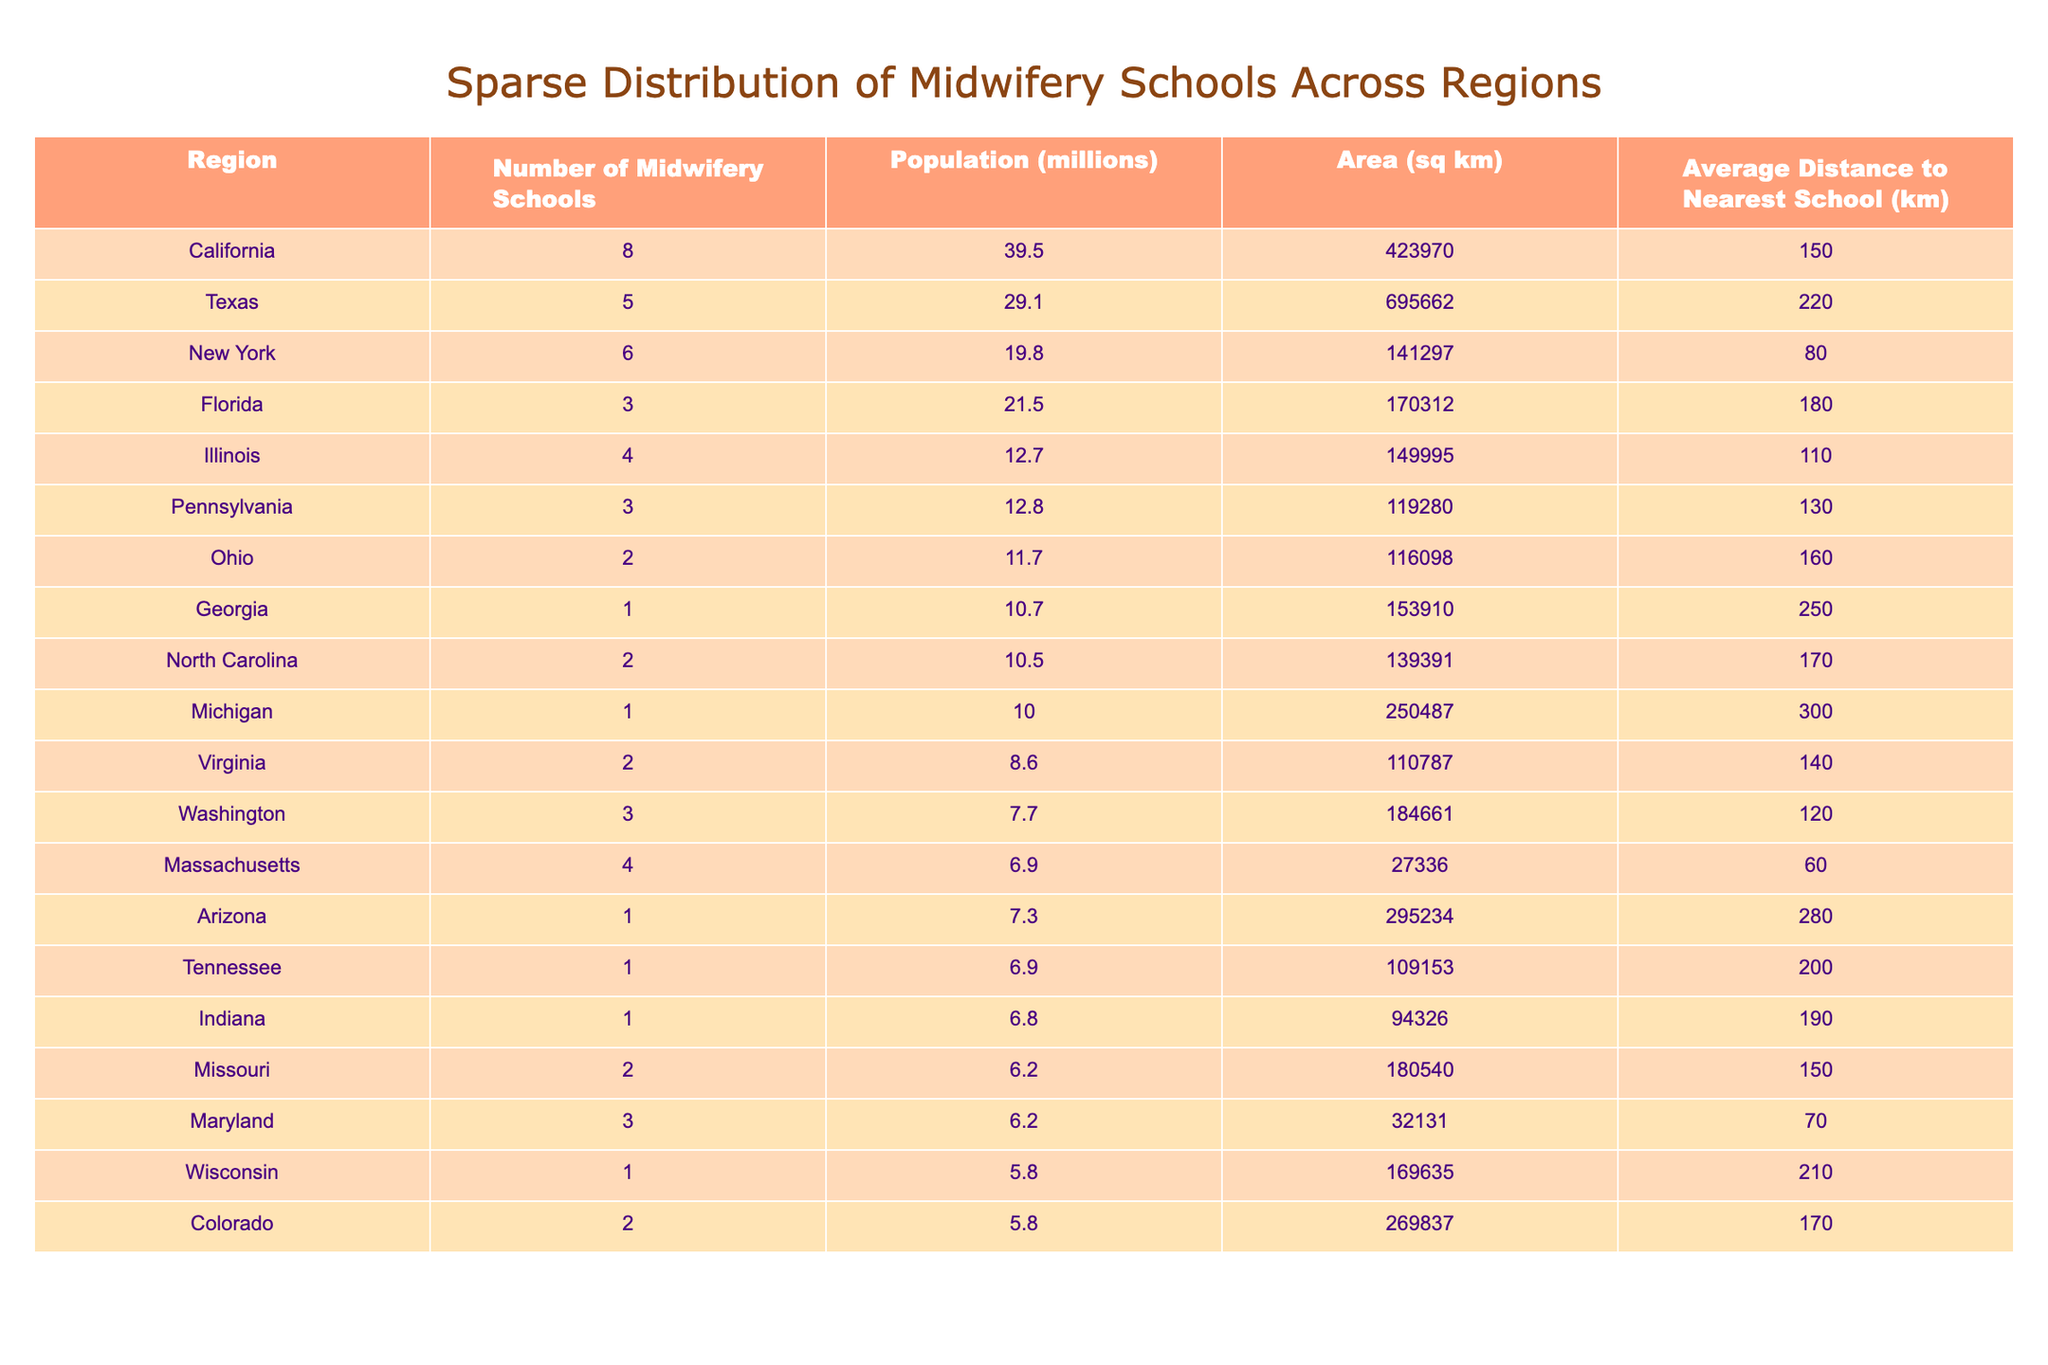What region has the highest number of midwifery schools? By looking at the "Number of Midwifery Schools" column, California has the highest number with 8 schools.
Answer: California Which region has the lowest average distance to the nearest midwifery school? The "Average Distance to Nearest School" column shows that Massachusetts has the lowest average distance at 60 km.
Answer: Massachusetts What is the total number of midwifery schools across all regions? To find the total, sum the values in the "Number of Midwifery Schools" column: 8 + 5 + 6 + 3 + 4 + 3 + 2 + 1 + 2 + 1 + 2 + 3 + 4 + 1 + 1 + 1 + 2 + 3 + 1 + 2 = 56.
Answer: 56 What is the average distance to the nearest midwifery school across all regions? First, calculate the sum of the "Average Distance to Nearest School" column (150 + 220 + 80 + 180 + 110 + 130 + 160 + 250 + 170 + 300 + 140 + 120 + 60 + 280 + 200 + 190 + 150 + 70 + 210 + 170 = 3080) and divide by 20 (the number of regions), resulting in an average of 154 km.
Answer: 154 km Is there a region with no midwifery schools? By checking the "Number of Midwifery Schools" column, Georgia, Michigan, Arizona, Tennessee, and Indiana each has only 1 school, indicating no region has zero schools.
Answer: No What is the total population of regions with more than 4 midwifery schools? First, identify the regions with more than 4 schools: California (39.5), Texas (29.1), and New York (19.8). Summing their populations gives 39.5 + 29.1 + 19.8 = 88.4 million.
Answer: 88.4 million Which region has the largest area and how many midwifery schools does it have? Comparing the "Area" column, Texas has the largest area at 695,662 sq km and has 5 midwifery schools.
Answer: Texas, 5 schools How many regions have fewer than 3 midwifery schools? Counting entries in the "Number of Midwifery Schools" column with values less than 3: Georgia (1), Michigan (1), Arizona (1), Tennessee (1), Indiana (1), resulting in 5 regions.
Answer: 5 regions What is the population density (population per sq km) in the region with the most midwifery schools? For California, divide the population (39.5 million) by the area (423,970 sq km), resulting in a density of approximately 93.32 people per sq km (39,500,000 / 423970).
Answer: Approximately 93.32 people/sq km Has the number of midwifery schools increased for any region? The data shows that over the regions listed, none have been shown to have an increase or decreases; therefore, we cannot conclude any changes based on this data alone.
Answer: No 